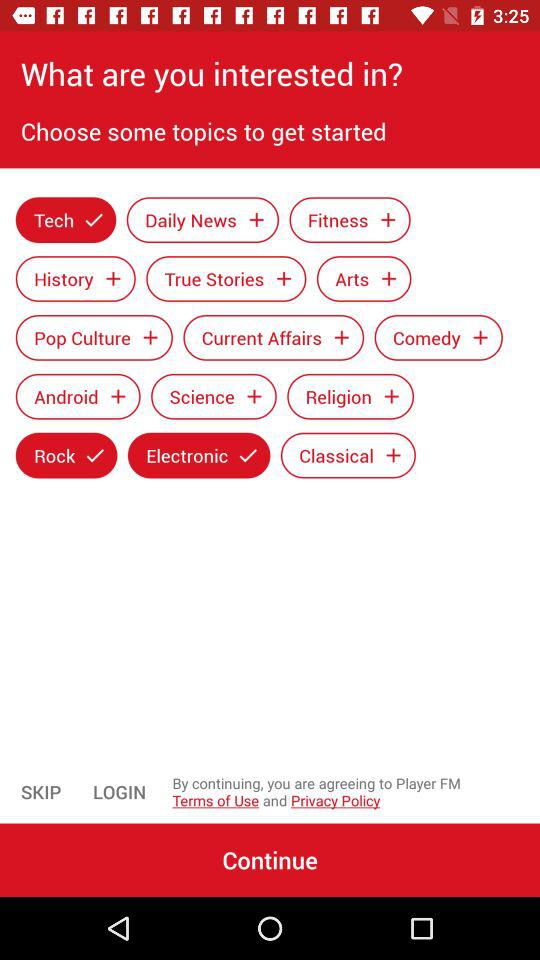Which are the different topics given to start? The different topics are "Tech", "Daily News", "Fitness", "History", "True Stories", "Arts", "Pop Culture", "Current Affairs", "Comedy", "Android", "Science", "Religion", "Rock", "Electronic" and "Classical". 